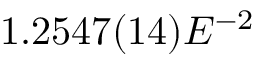Convert formula to latex. <formula><loc_0><loc_0><loc_500><loc_500>1 . 2 5 4 7 ( 1 4 ) E ^ { - 2 }</formula> 